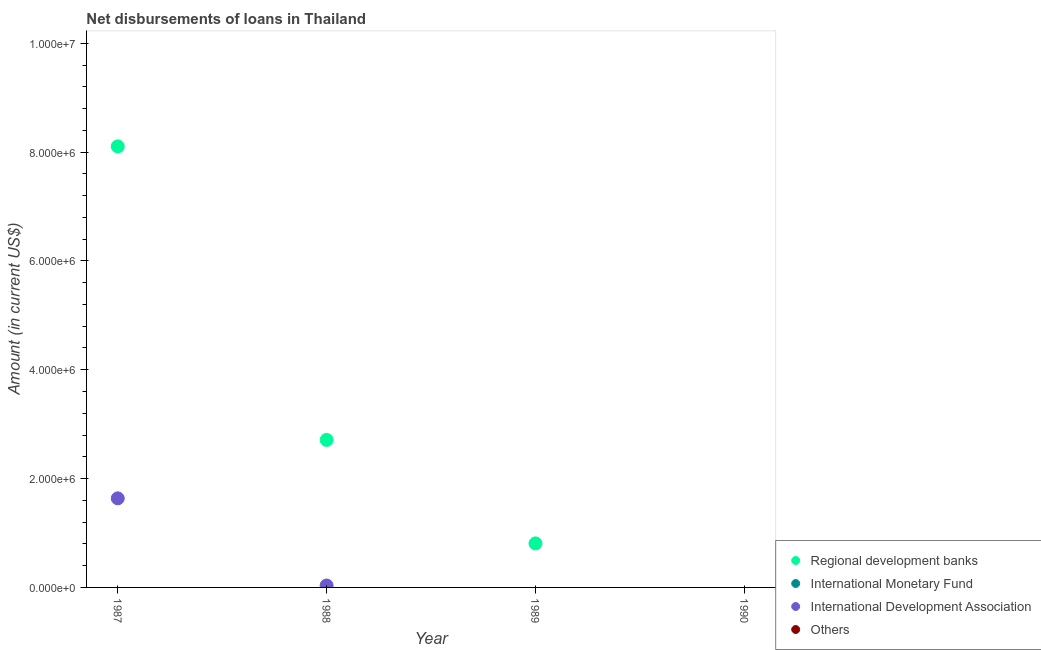Is the number of dotlines equal to the number of legend labels?
Provide a succinct answer. No. What is the amount of loan disimbursed by international development association in 1987?
Provide a short and direct response. 1.64e+06. Across all years, what is the maximum amount of loan disimbursed by international development association?
Your answer should be very brief. 1.64e+06. In which year was the amount of loan disimbursed by regional development banks maximum?
Your answer should be compact. 1987. What is the total amount of loan disimbursed by international development association in the graph?
Your answer should be very brief. 1.67e+06. What is the difference between the amount of loan disimbursed by regional development banks in 1988 and that in 1989?
Offer a very short reply. 1.90e+06. What is the average amount of loan disimbursed by international monetary fund per year?
Make the answer very short. 0. In the year 1987, what is the difference between the amount of loan disimbursed by international development association and amount of loan disimbursed by regional development banks?
Give a very brief answer. -6.47e+06. What is the ratio of the amount of loan disimbursed by regional development banks in 1987 to that in 1989?
Give a very brief answer. 10.02. What is the difference between the highest and the second highest amount of loan disimbursed by regional development banks?
Provide a short and direct response. 5.39e+06. What is the difference between the highest and the lowest amount of loan disimbursed by regional development banks?
Your answer should be very brief. 8.10e+06. In how many years, is the amount of loan disimbursed by international development association greater than the average amount of loan disimbursed by international development association taken over all years?
Provide a short and direct response. 1. Is the sum of the amount of loan disimbursed by regional development banks in 1988 and 1989 greater than the maximum amount of loan disimbursed by other organisations across all years?
Your response must be concise. Yes. Does the amount of loan disimbursed by international monetary fund monotonically increase over the years?
Your answer should be compact. Yes. Is the amount of loan disimbursed by other organisations strictly greater than the amount of loan disimbursed by international development association over the years?
Your response must be concise. No. How many dotlines are there?
Your answer should be compact. 2. How many years are there in the graph?
Keep it short and to the point. 4. Are the values on the major ticks of Y-axis written in scientific E-notation?
Your answer should be compact. Yes. Does the graph contain any zero values?
Offer a very short reply. Yes. How are the legend labels stacked?
Make the answer very short. Vertical. What is the title of the graph?
Make the answer very short. Net disbursements of loans in Thailand. Does "Secondary schools" appear as one of the legend labels in the graph?
Offer a very short reply. No. What is the label or title of the X-axis?
Make the answer very short. Year. What is the Amount (in current US$) of Regional development banks in 1987?
Offer a terse response. 8.10e+06. What is the Amount (in current US$) of International Development Association in 1987?
Offer a very short reply. 1.64e+06. What is the Amount (in current US$) in Regional development banks in 1988?
Your answer should be very brief. 2.71e+06. What is the Amount (in current US$) of International Development Association in 1988?
Offer a very short reply. 3.50e+04. What is the Amount (in current US$) of Others in 1988?
Offer a terse response. 0. What is the Amount (in current US$) in Regional development banks in 1989?
Offer a terse response. 8.09e+05. What is the Amount (in current US$) in International Monetary Fund in 1990?
Provide a short and direct response. 0. What is the Amount (in current US$) in Others in 1990?
Give a very brief answer. 0. Across all years, what is the maximum Amount (in current US$) in Regional development banks?
Offer a very short reply. 8.10e+06. Across all years, what is the maximum Amount (in current US$) of International Development Association?
Give a very brief answer. 1.64e+06. Across all years, what is the minimum Amount (in current US$) in Regional development banks?
Your response must be concise. 0. What is the total Amount (in current US$) in Regional development banks in the graph?
Offer a very short reply. 1.16e+07. What is the total Amount (in current US$) of International Monetary Fund in the graph?
Your answer should be very brief. 0. What is the total Amount (in current US$) in International Development Association in the graph?
Provide a short and direct response. 1.67e+06. What is the total Amount (in current US$) of Others in the graph?
Provide a short and direct response. 0. What is the difference between the Amount (in current US$) in Regional development banks in 1987 and that in 1988?
Provide a succinct answer. 5.39e+06. What is the difference between the Amount (in current US$) in International Development Association in 1987 and that in 1988?
Ensure brevity in your answer.  1.60e+06. What is the difference between the Amount (in current US$) of Regional development banks in 1987 and that in 1989?
Your answer should be very brief. 7.30e+06. What is the difference between the Amount (in current US$) in Regional development banks in 1988 and that in 1989?
Give a very brief answer. 1.90e+06. What is the difference between the Amount (in current US$) in Regional development banks in 1987 and the Amount (in current US$) in International Development Association in 1988?
Provide a succinct answer. 8.07e+06. What is the average Amount (in current US$) in Regional development banks per year?
Your answer should be compact. 2.91e+06. What is the average Amount (in current US$) in International Development Association per year?
Your response must be concise. 4.18e+05. In the year 1987, what is the difference between the Amount (in current US$) in Regional development banks and Amount (in current US$) in International Development Association?
Offer a terse response. 6.47e+06. In the year 1988, what is the difference between the Amount (in current US$) in Regional development banks and Amount (in current US$) in International Development Association?
Offer a very short reply. 2.68e+06. What is the ratio of the Amount (in current US$) in Regional development banks in 1987 to that in 1988?
Your answer should be compact. 2.99. What is the ratio of the Amount (in current US$) in International Development Association in 1987 to that in 1988?
Ensure brevity in your answer.  46.77. What is the ratio of the Amount (in current US$) of Regional development banks in 1987 to that in 1989?
Your answer should be very brief. 10.02. What is the ratio of the Amount (in current US$) of Regional development banks in 1988 to that in 1989?
Your answer should be very brief. 3.35. What is the difference between the highest and the second highest Amount (in current US$) of Regional development banks?
Provide a succinct answer. 5.39e+06. What is the difference between the highest and the lowest Amount (in current US$) of Regional development banks?
Make the answer very short. 8.10e+06. What is the difference between the highest and the lowest Amount (in current US$) in International Development Association?
Keep it short and to the point. 1.64e+06. 